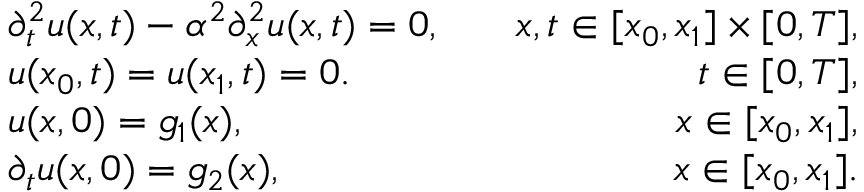Convert formula to latex. <formula><loc_0><loc_0><loc_500><loc_500>\begin{array} { r l r } & { \partial _ { t } ^ { 2 } u ( x , t ) - \alpha ^ { 2 } \partial _ { x } ^ { 2 } u ( x , t ) = 0 , } & { \quad x , t \in [ x _ { 0 } , x _ { 1 } ] \times [ 0 , T ] , } \\ & { u ( x _ { 0 } , t ) = u ( x _ { 1 } , t ) = 0 . } & { \quad t \in [ 0 , T ] , } \\ & { u ( x , 0 ) = g _ { 1 } ( x ) , } & { \quad x \in [ x _ { 0 } , x _ { 1 } ] , } \\ & { \partial _ { t } u ( x , 0 ) = g _ { 2 } ( x ) , } & { \quad x \in [ x _ { 0 } , x _ { 1 } ] . } \end{array}</formula> 